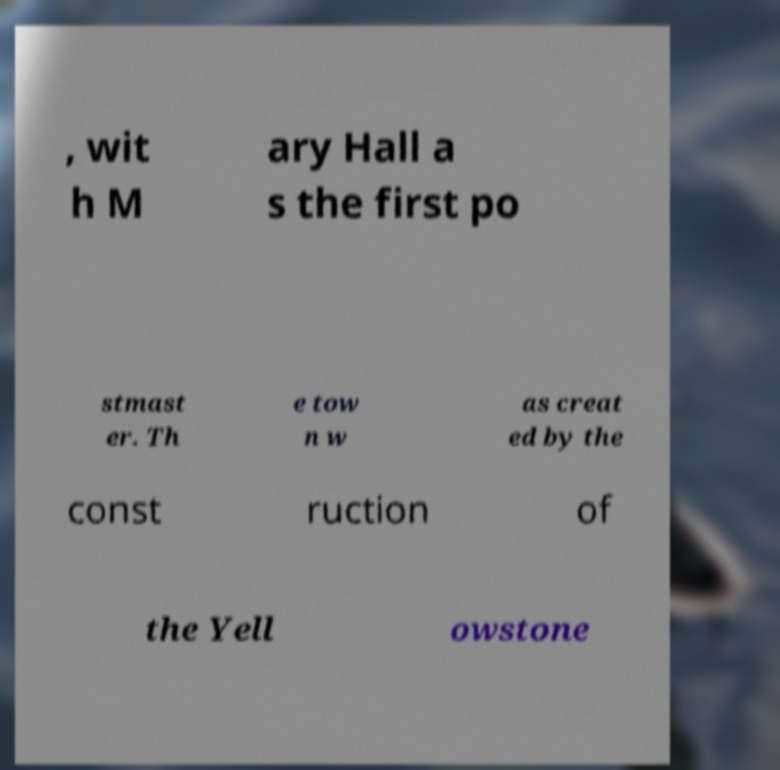Please read and relay the text visible in this image. What does it say? , wit h M ary Hall a s the first po stmast er. Th e tow n w as creat ed by the const ruction of the Yell owstone 